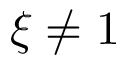Convert formula to latex. <formula><loc_0><loc_0><loc_500><loc_500>\xi \neq 1</formula> 